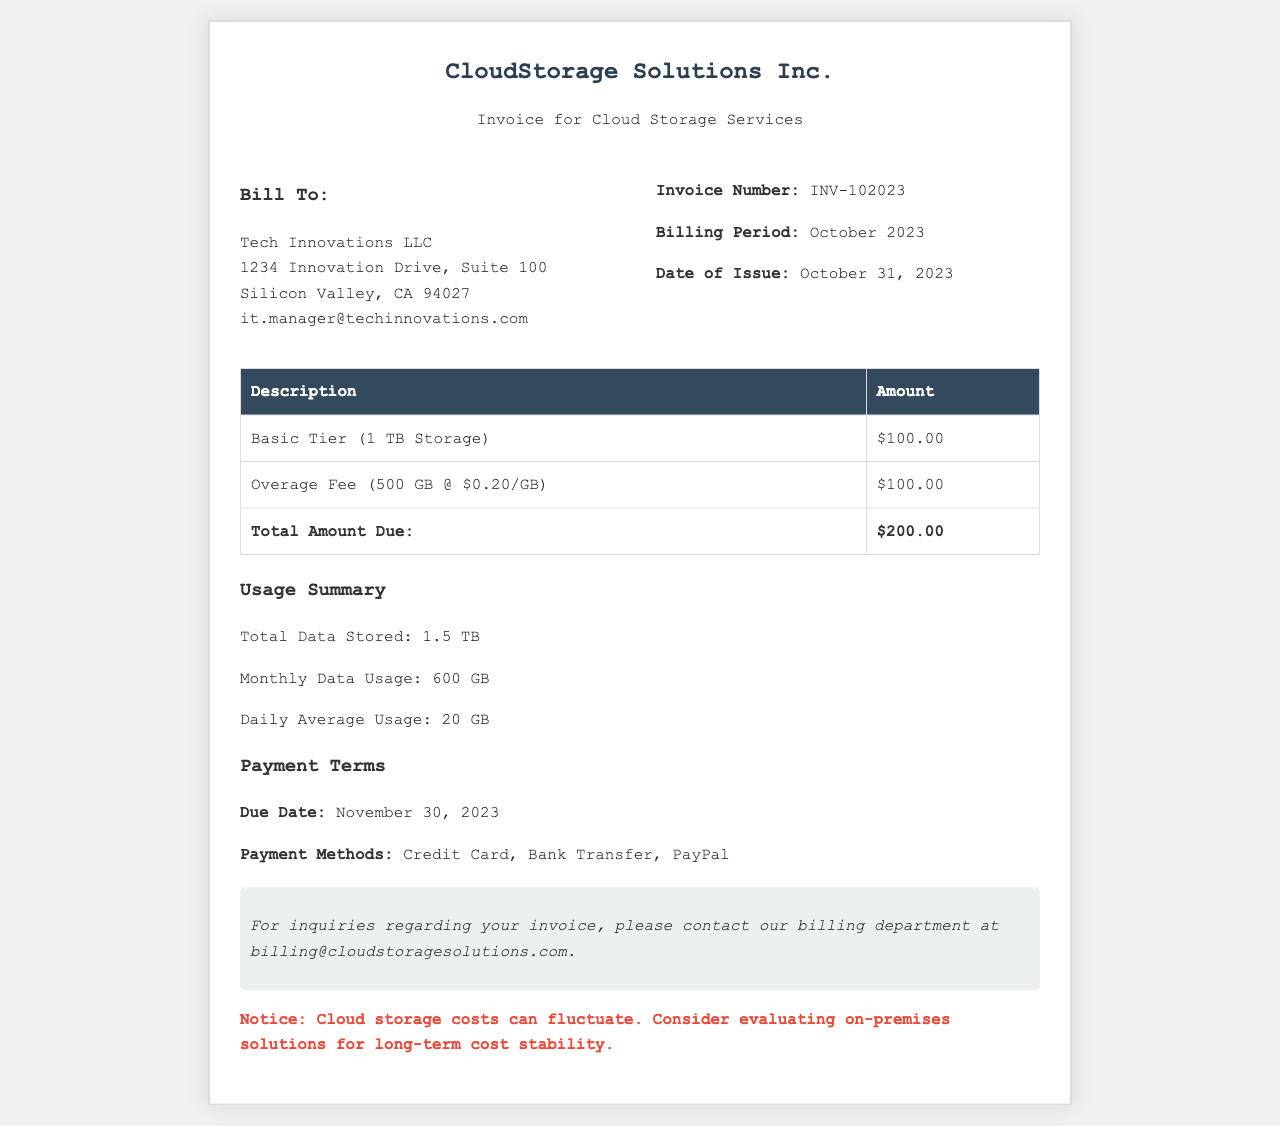What is the total amount due? The total amount due is the sum of the charges listed in the invoice, which is $100.00 for the Basic Tier and $100.00 for the overage fee.
Answer: $200.00 What is the invoice number? The invoice number is clearly stated in the invoice section, labeled as "Invoice Number."
Answer: INV-102023 How much is charged for the overage fee? The overage fee is specified in the table of charges, showing the amount for additional data usage.
Answer: $100.00 What is the billing period? The billing period is indicated in the invoice info section, specifying the timeframe for the charges.
Answer: October 2023 What is the due date for the payment? The due date is provided under payment terms, indicating when the payment should be made.
Answer: November 30, 2023 What is the total data stored? The total data stored is summarized in the usage summary section of the invoice, detailing the amount of storage used.
Answer: 1.5 TB What payment methods are accepted? Accepted payment methods are listed in the payment terms, mentioning multiple options for settling the invoice.
Answer: Credit Card, Bank Transfer, PayPal What is the basic tier storage amount? The basic tier storage amount is specified in the invoice table for the charges listed.
Answer: $100.00 What is the daily average usage? The daily average usage is provided in the usage summary section of the invoice, indicating the typical data usage per day.
Answer: 20 GB 